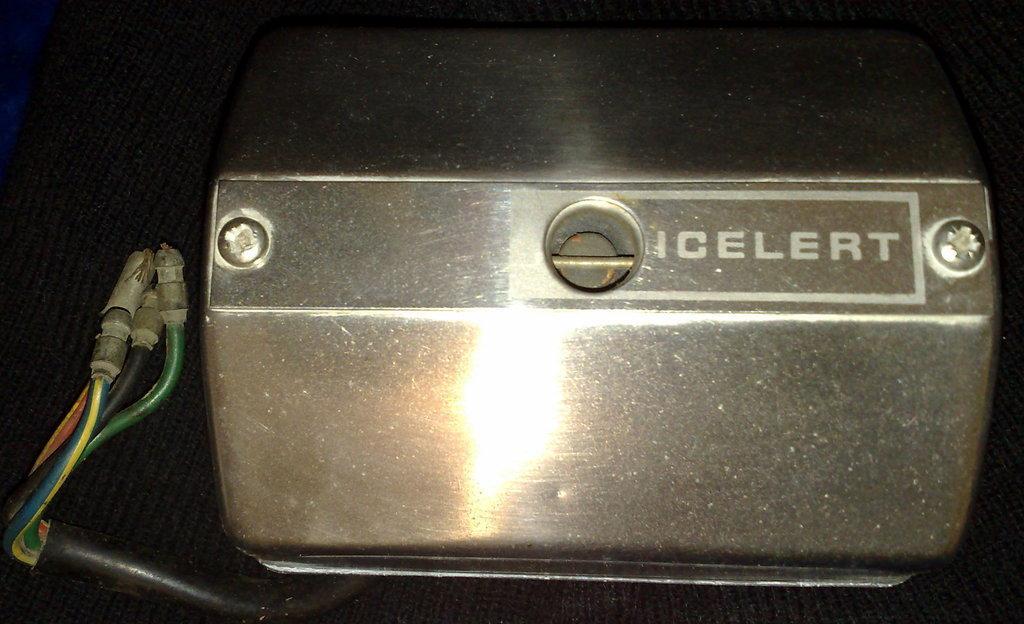Please provide a concise description of this image. In this picture we can see screws to a metal box, cables, some objects and these all are placed on a black cloth. 